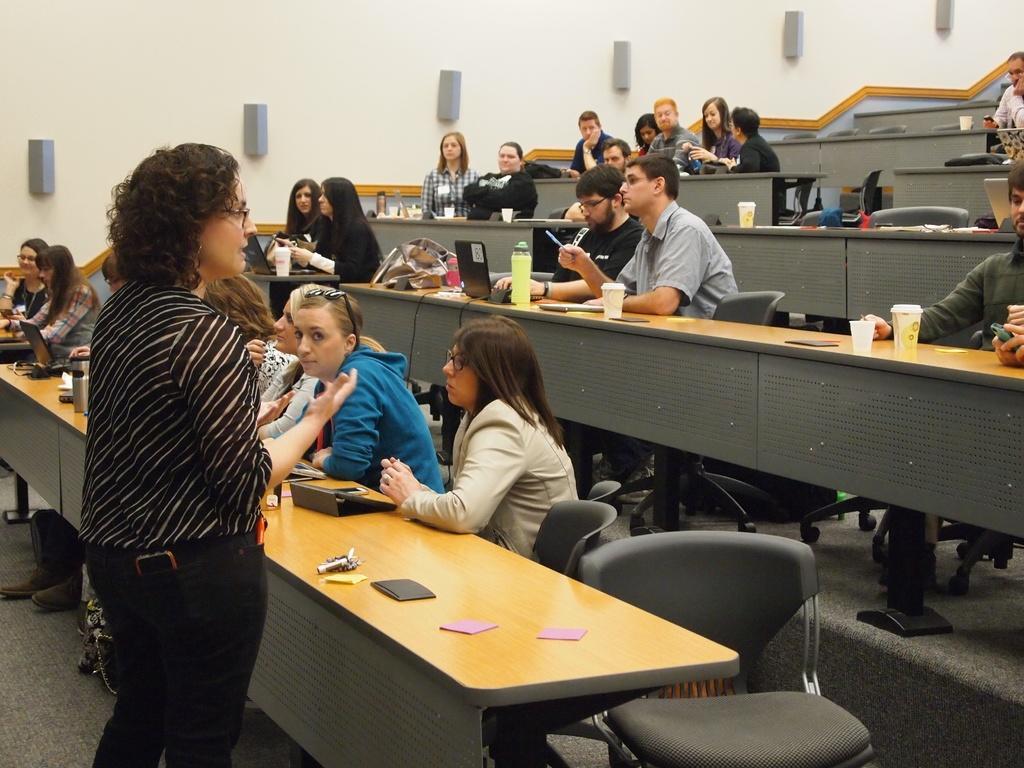How would you summarize this image in a sentence or two? A woman is giving a lecture in classroom. There are group of students listening to her sitting in benches. 